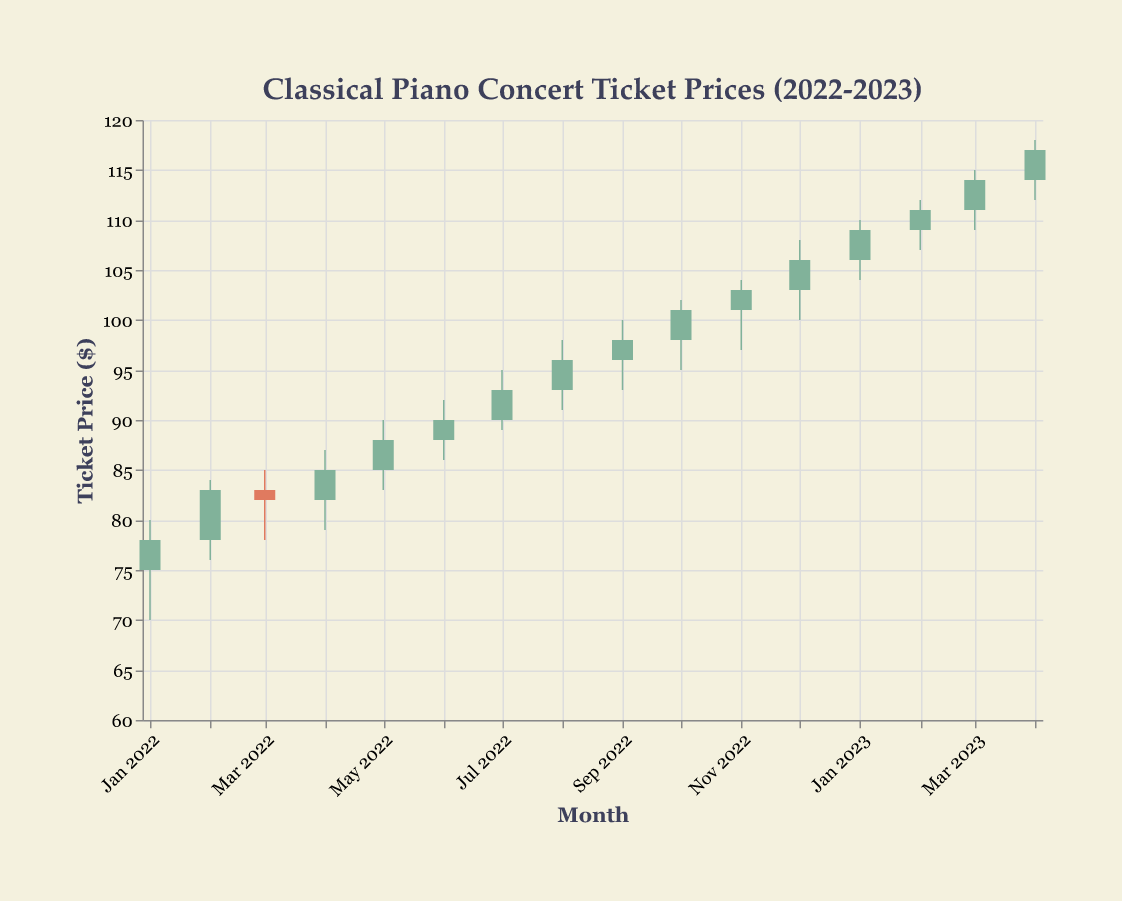What's the title of the figure? The title is positioned at the top of the figure. It reads "Classical Piano Concert Ticket Prices (2022-2023)".
Answer: Classical Piano Concert Ticket Prices (2022-2023) How many months of data are shown in the figure? The data list months from Jan-2022 to Apr-2023, which totals 16 months.
Answer: 16 months What was the highest ticket price recorded, and in which month? The highest price can be found at the peak of the High value. This happens in Apr-2023 with a high of $118.
Answer: $118 in Apr-2023 Did the ticket price in Feb-2022 close higher or lower than it opened? In Feb-2022, the price opened at $78 and closed at $83. Since $83 is higher than $78, it closed higher.
Answer: Higher Which month showed the greatest difference between the high and low prices? To find this, calculate the difference between High and Low for each month. Apr-2022 had the highest difference: $87 - $79 = $8.
Answer: Apr-2022 What was the closing price in Dec-2022? The closing price for Dec-2022 is shown directly in the Jan 2022 data row under Close. It reads $106.
Answer: $106 Compare the opening and closing prices in Jul-2022. What can you infer? In Jul-2022, the opening price was $90, and the closing price was $93. The closing price is higher than the opening price, implying that ticket prices increased.
Answer: Prices increased What's the trend from Jan-2022 to Apr-2023 in terms of general increase or decrease? To deduce the trend, observe the opening prices from Jan-2022 ($75) to Apr-2023 ($114). The prices increased over this period.
Answer: Increased Which month had the smallest range between the high and low prices? Calculate the difference between high and low for each month. Mar-2023 had the smallest range: $115 - $109 = $6.
Answer: Mar-2023 What patterns can you observe from the color-coding in the plot? The colors represent whether the closing price is higher (green) or lower (red) than the opening price. Most months show green bars indicating an upward trend.
Answer: Upward trend 